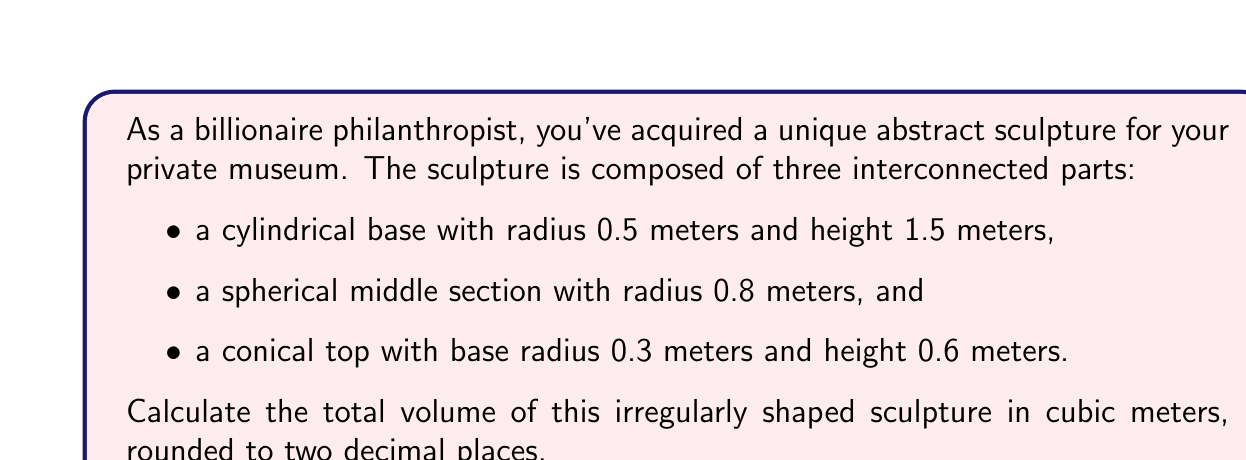Teach me how to tackle this problem. To calculate the total volume of this irregularly shaped sculpture, we need to calculate the volume of each component and then sum them up.

1. Cylindrical base:
   The volume of a cylinder is given by $V_{cylinder} = \pi r^2 h$
   $$V_{base} = \pi (0.5\text{ m})^2 (1.5\text{ m}) = 1.1781\text{ m}^3$$

2. Spherical middle section:
   The volume of a sphere is given by $V_{sphere} = \frac{4}{3}\pi r^3$
   $$V_{middle} = \frac{4}{3}\pi (0.8\text{ m})^3 = 2.1451\text{ m}^3$$

3. Conical top:
   The volume of a cone is given by $V_{cone} = \frac{1}{3}\pi r^2 h$
   $$V_{top} = \frac{1}{3}\pi (0.3\text{ m})^2 (0.6\text{ m}) = 0.0565\text{ m}^3$$

Now, we sum up the volumes of all three components:

$$V_{total} = V_{base} + V_{middle} + V_{top}$$
$$V_{total} = 1.1781\text{ m}^3 + 2.1451\text{ m}^3 + 0.0565\text{ m}^3 = 3.3797\text{ m}^3$$

Rounding to two decimal places, we get 3.38 m³.
Answer: 3.38 m³ 